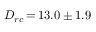Convert formula to latex. <formula><loc_0><loc_0><loc_500><loc_500>D _ { r c } \, { = } \, 1 3 . 0 \pm 1 . 9</formula> 